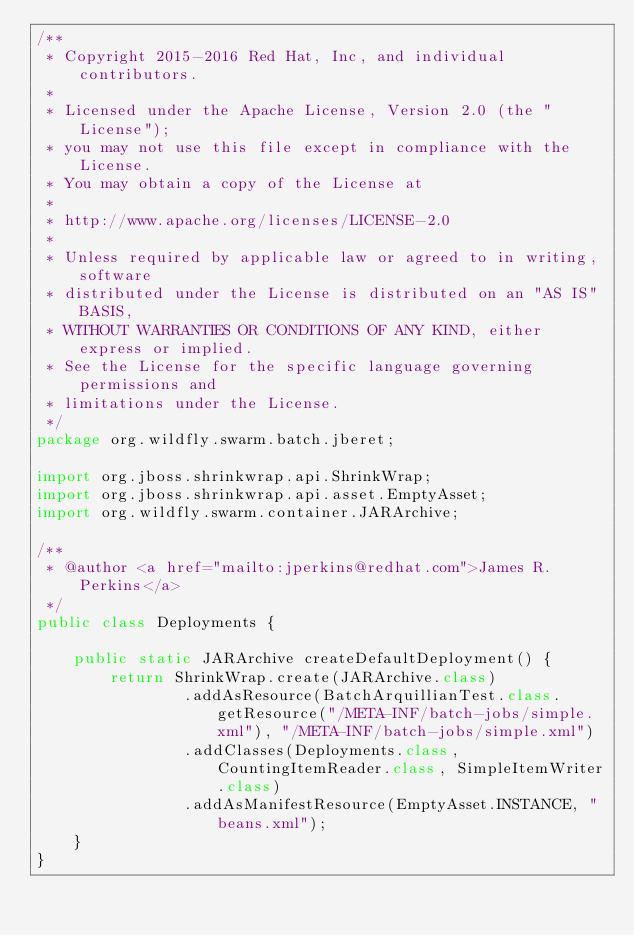<code> <loc_0><loc_0><loc_500><loc_500><_Java_>/**
 * Copyright 2015-2016 Red Hat, Inc, and individual contributors.
 *
 * Licensed under the Apache License, Version 2.0 (the "License");
 * you may not use this file except in compliance with the License.
 * You may obtain a copy of the License at
 *
 * http://www.apache.org/licenses/LICENSE-2.0
 *
 * Unless required by applicable law or agreed to in writing, software
 * distributed under the License is distributed on an "AS IS" BASIS,
 * WITHOUT WARRANTIES OR CONDITIONS OF ANY KIND, either express or implied.
 * See the License for the specific language governing permissions and
 * limitations under the License.
 */
package org.wildfly.swarm.batch.jberet;

import org.jboss.shrinkwrap.api.ShrinkWrap;
import org.jboss.shrinkwrap.api.asset.EmptyAsset;
import org.wildfly.swarm.container.JARArchive;

/**
 * @author <a href="mailto:jperkins@redhat.com">James R. Perkins</a>
 */
public class Deployments {

    public static JARArchive createDefaultDeployment() {
        return ShrinkWrap.create(JARArchive.class)
                .addAsResource(BatchArquillianTest.class.getResource("/META-INF/batch-jobs/simple.xml"), "/META-INF/batch-jobs/simple.xml")
                .addClasses(Deployments.class, CountingItemReader.class, SimpleItemWriter.class)
                .addAsManifestResource(EmptyAsset.INSTANCE, "beans.xml");
    }
}
</code> 